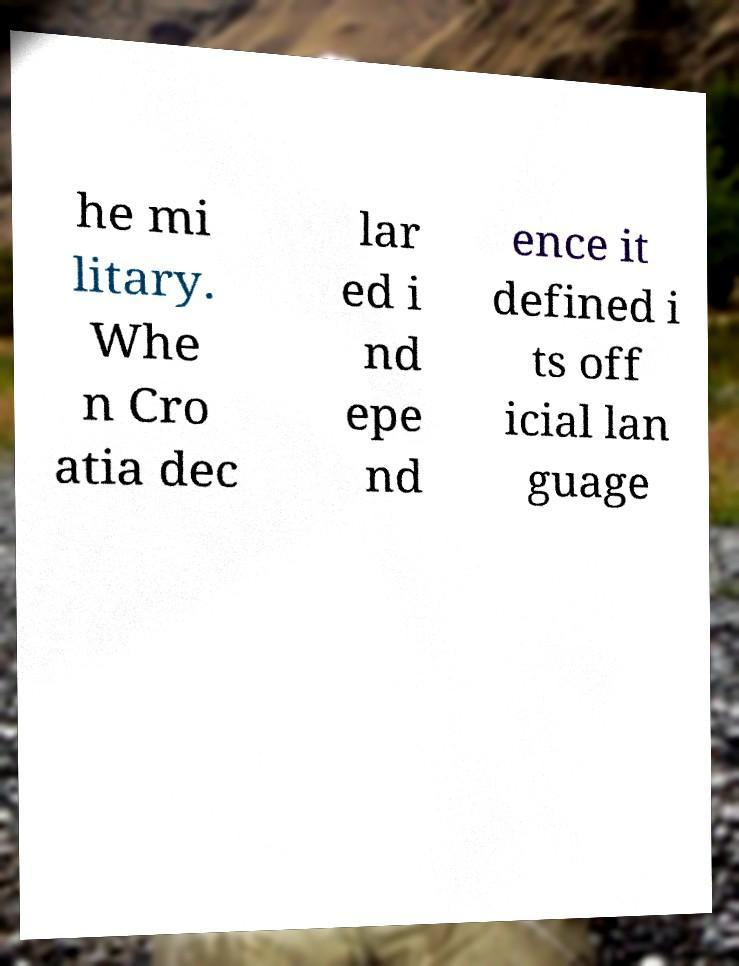I need the written content from this picture converted into text. Can you do that? he mi litary. Whe n Cro atia dec lar ed i nd epe nd ence it defined i ts off icial lan guage 